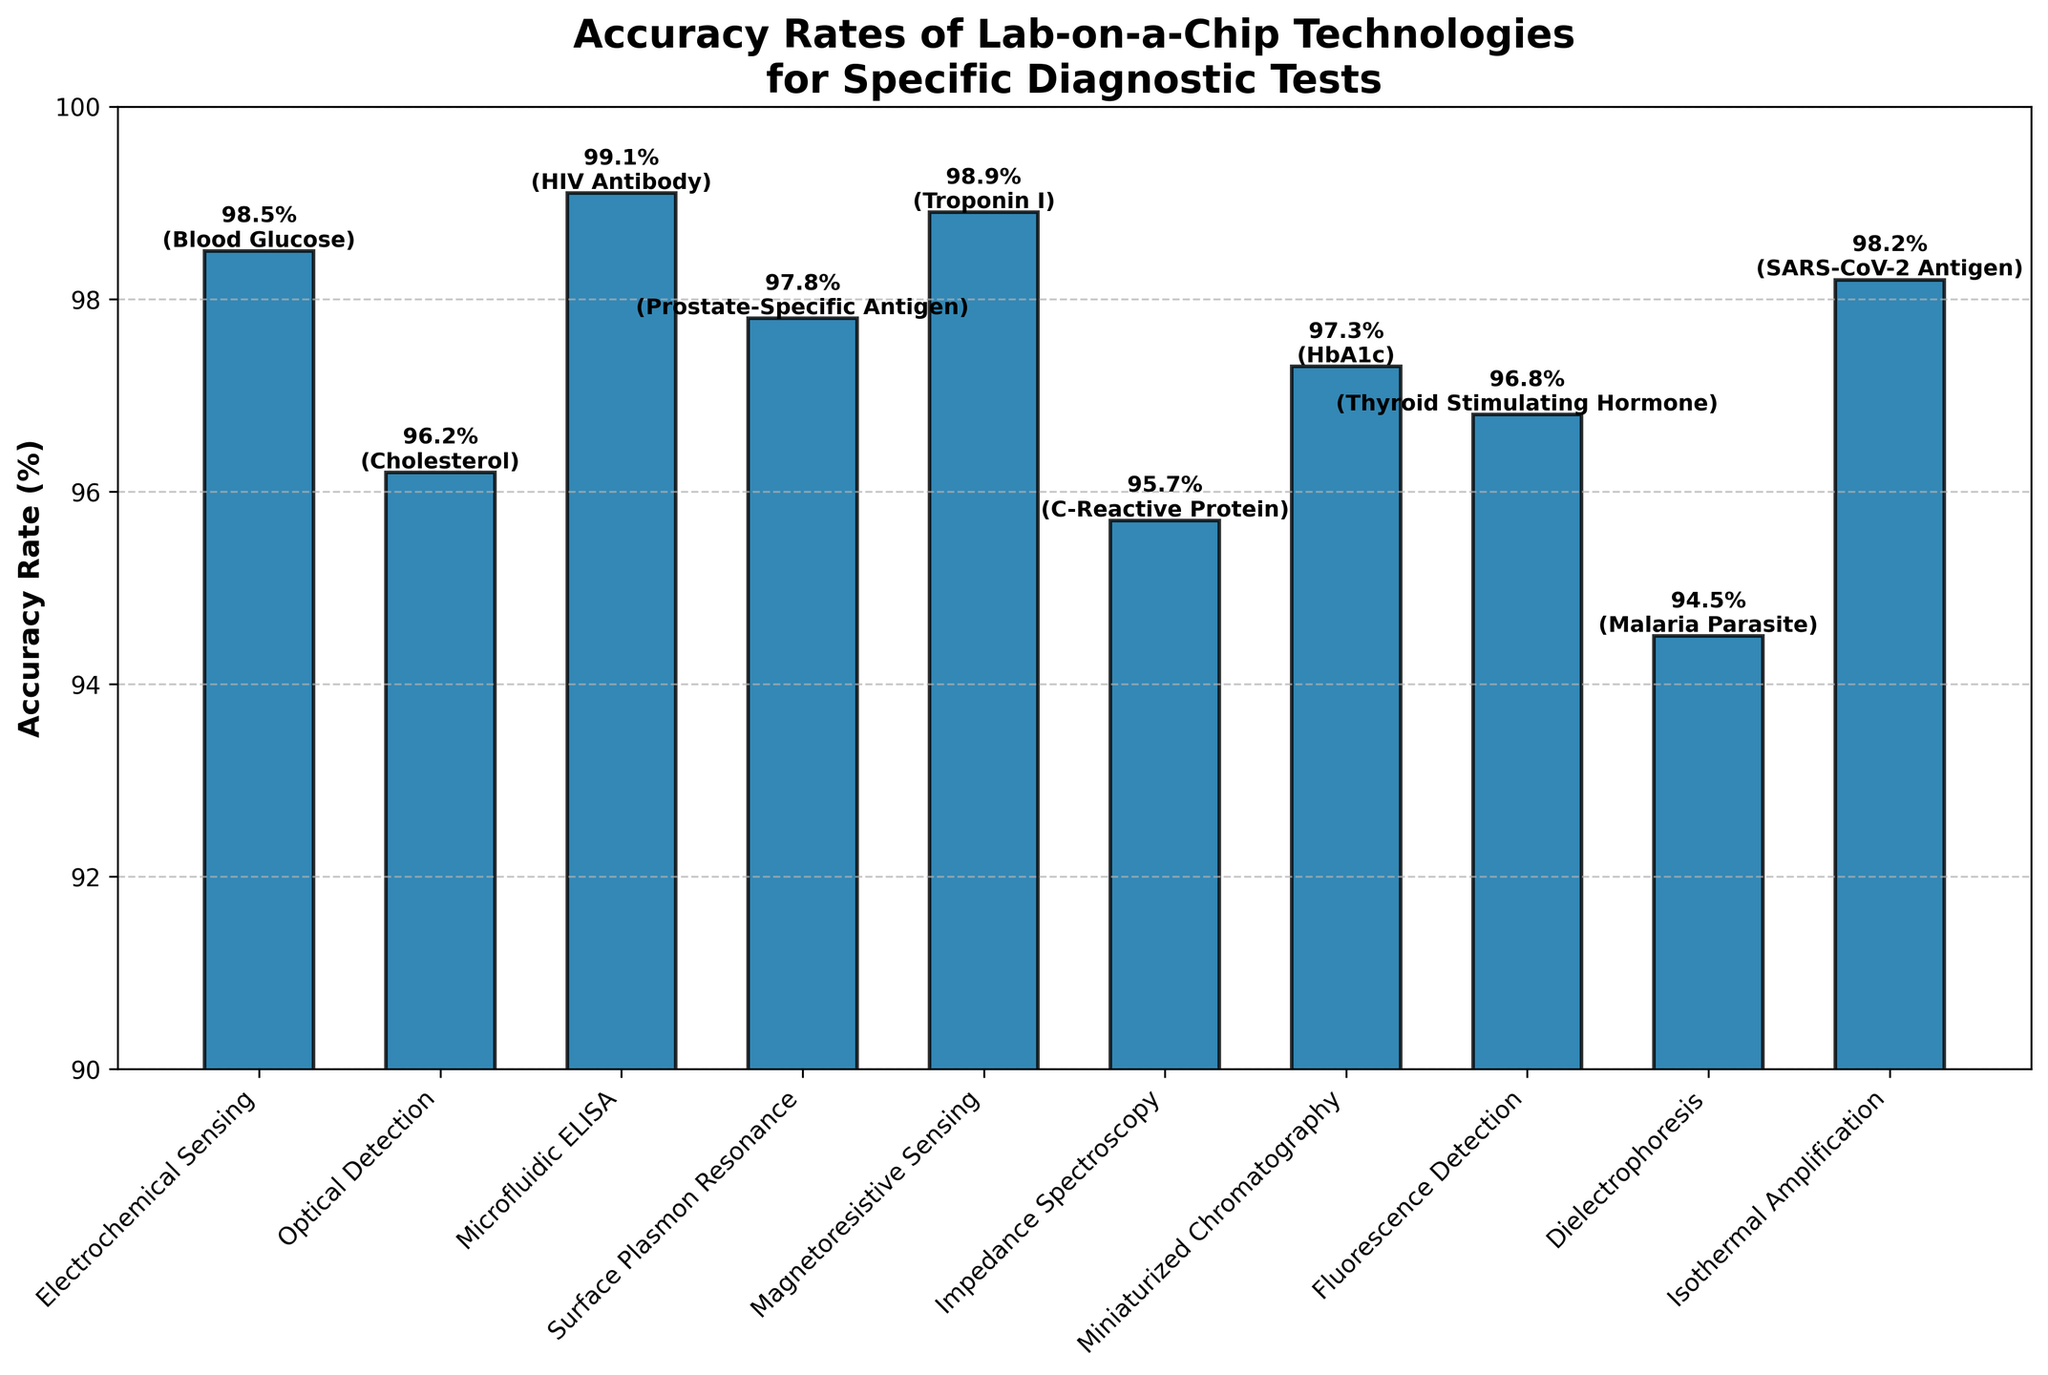What's the highest accuracy rate among the lab-on-a-chip technologies? Identify the bar with the highest value, which is for HIV Antibody with Microfluidic ELISA technology at 99.1%.
Answer: 99.1% Which diagnostic test has the lowest accuracy rate? Look for the shortest bar which corresponds to Malaria Parasite using Dielectrophoresis technology with an accuracy rate of 94.5%.
Answer: Malaria Parasite Which two diagnostic tests have an accuracy rate above 98.5%? Identify the bars that exceed the height corresponding to 98.5%. These are Blood Glucose (Electrochemical Sensing) at 98.5% and HIV Antibody (Microfluidic ELISA) at 99.1%.
Answer: Blood Glucose and HIV Antibody How much higher is the accuracy rate of Microfluidic ELISA compared to Impedance Spectroscopy? Subtract the accuracy rate of Impedance Spectroscopy (95.7%) from that of Microfluidic ELISA (99.1%). The difference is 99.1% - 95.7% = 3.4%.
Answer: 3.4% Which technology is used for the diagnostic test with the median accuracy rate? List the accuracy rates and identify the median value. The rates are 99.1%, 98.9%, 98.5%, 98.2%, 97.8%, 97.3%, 96.8%, 96.2%, 95.7%, and 94.5%. The median is the average of the 5th and 6th sorted values (97.3% and 97.8%), giving a median of 97.55%. The test closest to this value is HbA1c with Miniaturized Chromatography (97.3%).
Answer: Miniaturized Chromatography List the tests that have accuracy rates within 1% of each other. Group accuracy rates within a 1% difference: 98.9% (Troponin I) and 98.5% (Blood Glucose); 97.8% (Prostate-Specific Antigen) and 97.3% (HbA1c); 96.8% (Thyroid Stimulating Hormone) and 96.2% (Cholesterol).
Answer: Blood Glucose and Troponin I, Prostate-Specific Antigen and HbA1c, Thyroid Stimulating Hormone and Cholesterol Which test has a higher accuracy rate: SARS-CoV-2 Antigen or Thyroid Stimulating Hormone? Compare the bars for these two tests. SARS-CoV-2 Antigen (Isothermal Amplification) has 98.2% and Thyroid Stimulating Hormone (Fluorescence Detection) has 96.8%.
Answer: SARS-CoV-2 Antigen 